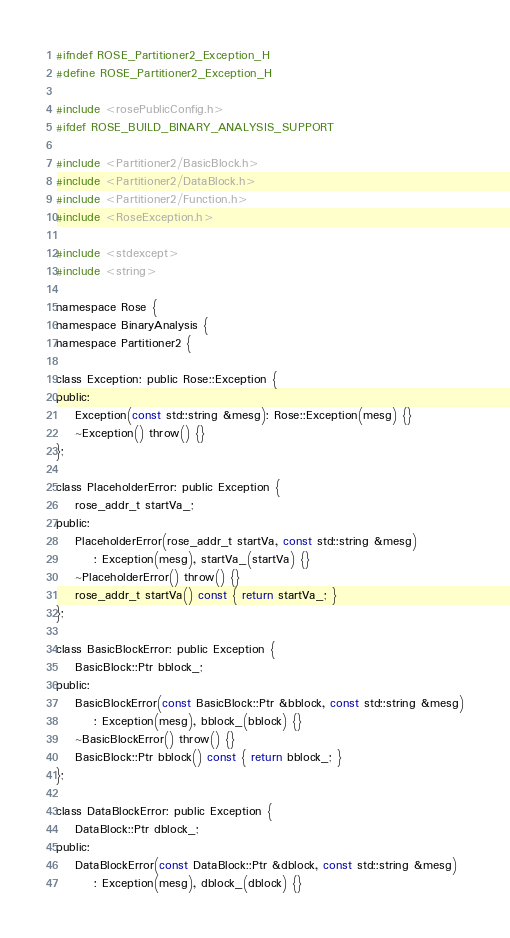Convert code to text. <code><loc_0><loc_0><loc_500><loc_500><_C_>#ifndef ROSE_Partitioner2_Exception_H
#define ROSE_Partitioner2_Exception_H

#include <rosePublicConfig.h>
#ifdef ROSE_BUILD_BINARY_ANALYSIS_SUPPORT

#include <Partitioner2/BasicBlock.h>
#include <Partitioner2/DataBlock.h>
#include <Partitioner2/Function.h>
#include <RoseException.h>

#include <stdexcept>
#include <string>

namespace Rose {
namespace BinaryAnalysis {
namespace Partitioner2 {

class Exception: public Rose::Exception {
public:
    Exception(const std::string &mesg): Rose::Exception(mesg) {}
    ~Exception() throw() {}
};

class PlaceholderError: public Exception {
    rose_addr_t startVa_;
public:
    PlaceholderError(rose_addr_t startVa, const std::string &mesg)
        : Exception(mesg), startVa_(startVa) {}
    ~PlaceholderError() throw() {}
    rose_addr_t startVa() const { return startVa_; }
};

class BasicBlockError: public Exception {
    BasicBlock::Ptr bblock_;
public:
    BasicBlockError(const BasicBlock::Ptr &bblock, const std::string &mesg)
        : Exception(mesg), bblock_(bblock) {}
    ~BasicBlockError() throw() {}
    BasicBlock::Ptr bblock() const { return bblock_; }
};

class DataBlockError: public Exception {
    DataBlock::Ptr dblock_;
public:
    DataBlockError(const DataBlock::Ptr &dblock, const std::string &mesg)
        : Exception(mesg), dblock_(dblock) {}</code> 